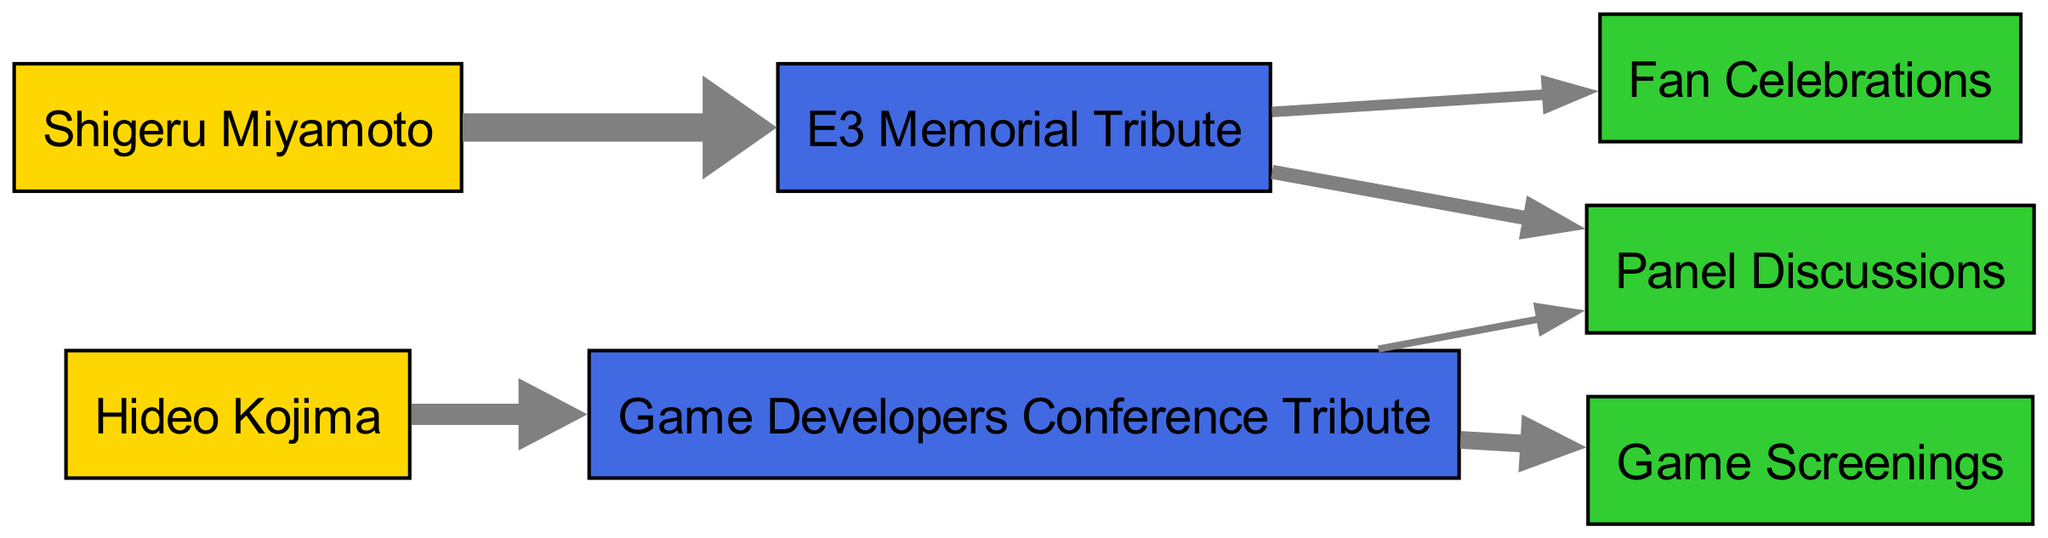What is the total number of nodes in the diagram? The diagram includes nodes for "Shigeru Miyamoto," "Hideo Kojima," "E3 Memorial Tribute," "Game Developers Conference Tribute," "Panel Discussions," "Fan Celebrations," and "Game Screenings." Counting these gives a total of 6 nodes.
Answer: 6 Which memorial event is associated with Shigeru Miyamoto? The diagram shows a link from "Shigeru Miyamoto" to "E3 Memorial Tribute." This indicates that he is associated with this event.
Answer: E3 Memorial Tribute What activity is connected to the Game Developers Conference Tribute with the highest value? In the diagram, "Game Developers Conference Tribute" has two linked activities: "Game Screenings" and "Panel Discussions." The value for "Game Screenings" is 25, while that for "Panel Discussions" is 10. The higher value indicates that "Game Screenings" is more significant.
Answer: Game Screenings How many connections does the Game Developers Conference Tribute have? Looking at the diagram, "Game Developers Conference Tribute" is connected to two activities: "Game Screenings" and "Panel Discussions." Therefore, it has 2 connections.
Answer: 2 Which activity has the lowest connection value and to which memorial event is it linked? The activity "Panel Discussions" linked to "E3 Memorial Tribute" has a connection value of 20, while the link to "Game Developers Conference Tribute" has a value of 10. Comparing these, "Panel Discussions" linked to "Game Developers Conference Tribute" has the lowest value of 10.
Answer: 10, Game Developers Conference Tribute What is the total value of connections for the E3 Memorial Tribute? The E3 Memorial Tribute connects to "Panel Discussions" (20) and "Fan Celebrations" (15). By adding these values (20 + 15), we get a total connection value of 35 for E3 Memorial Tribute.
Answer: 35 Which legendary creator is associated with the highest total attendance value across events? Since "Shigeru Miyamoto" is linked to "E3 Memorial Tribute" with a value of 40 and "Hideo Kojima" has a value of 30 with "Game Developers Conference Tribute," combining both connections shows that Shigeru Miyamoto has the highest total attendance value.
Answer: Shigeru Miyamoto What is the sum of values for activities related to the E3 Memorial Tribute? The activities related to "E3 Memorial Tribute" are "Panel Discussions" (20) and "Fan Celebrations" (15). Adding these values gives a total of 35 for activities related to this event.
Answer: 35 